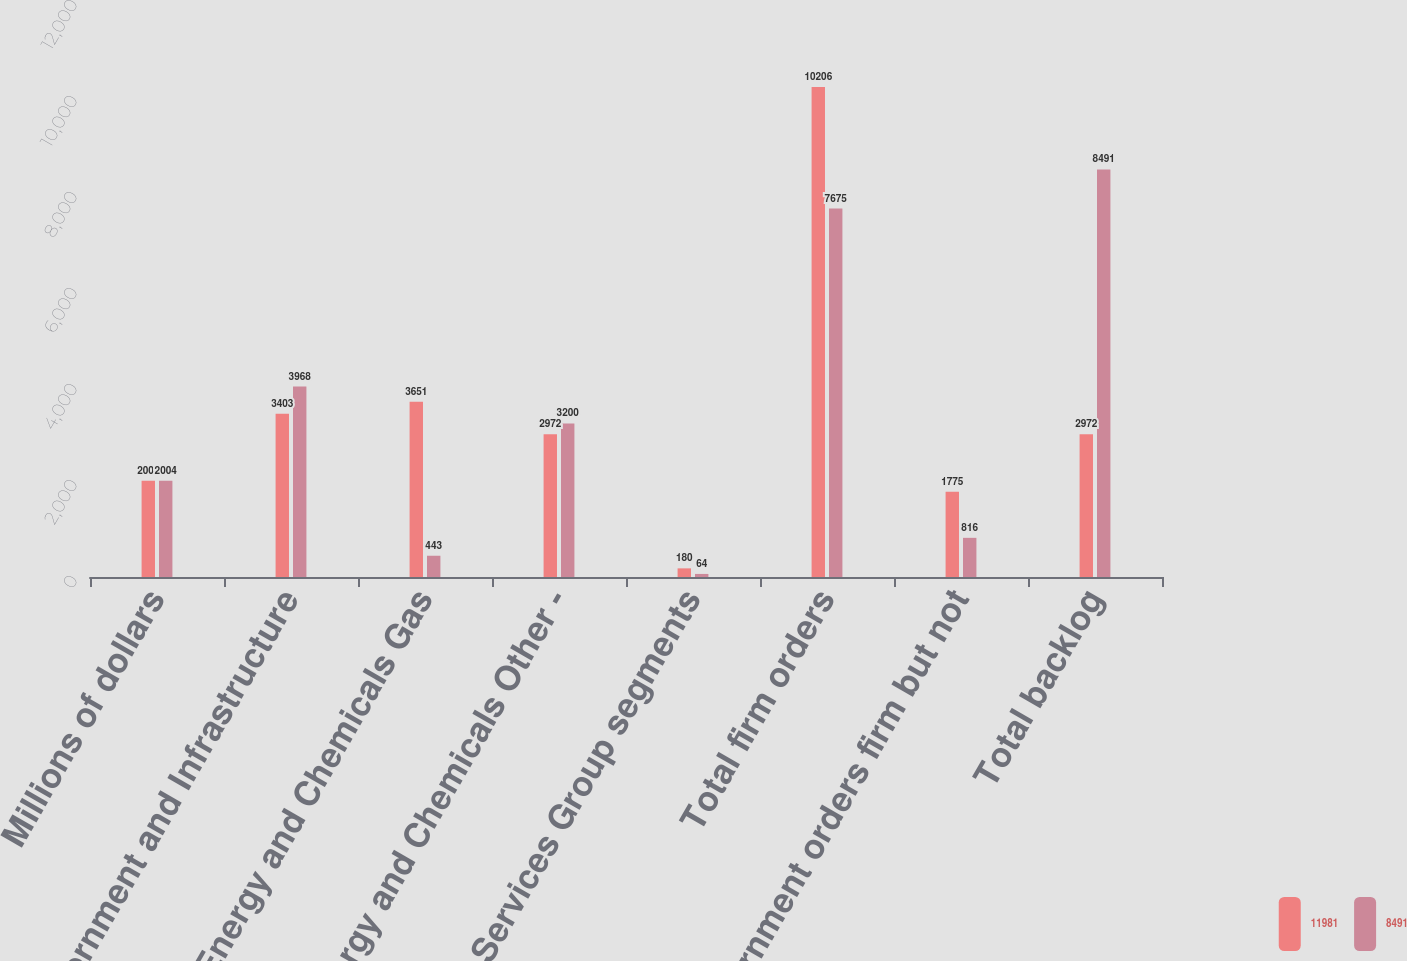Convert chart to OTSL. <chart><loc_0><loc_0><loc_500><loc_500><stacked_bar_chart><ecel><fcel>Millions of dollars<fcel>Government and Infrastructure<fcel>Energy and Chemicals Gas<fcel>Energy and Chemicals Other -<fcel>Energy Services Group segments<fcel>Total firm orders<fcel>Government orders firm but not<fcel>Total backlog<nl><fcel>11981<fcel>2005<fcel>3403<fcel>3651<fcel>2972<fcel>180<fcel>10206<fcel>1775<fcel>2972<nl><fcel>8491<fcel>2004<fcel>3968<fcel>443<fcel>3200<fcel>64<fcel>7675<fcel>816<fcel>8491<nl></chart> 